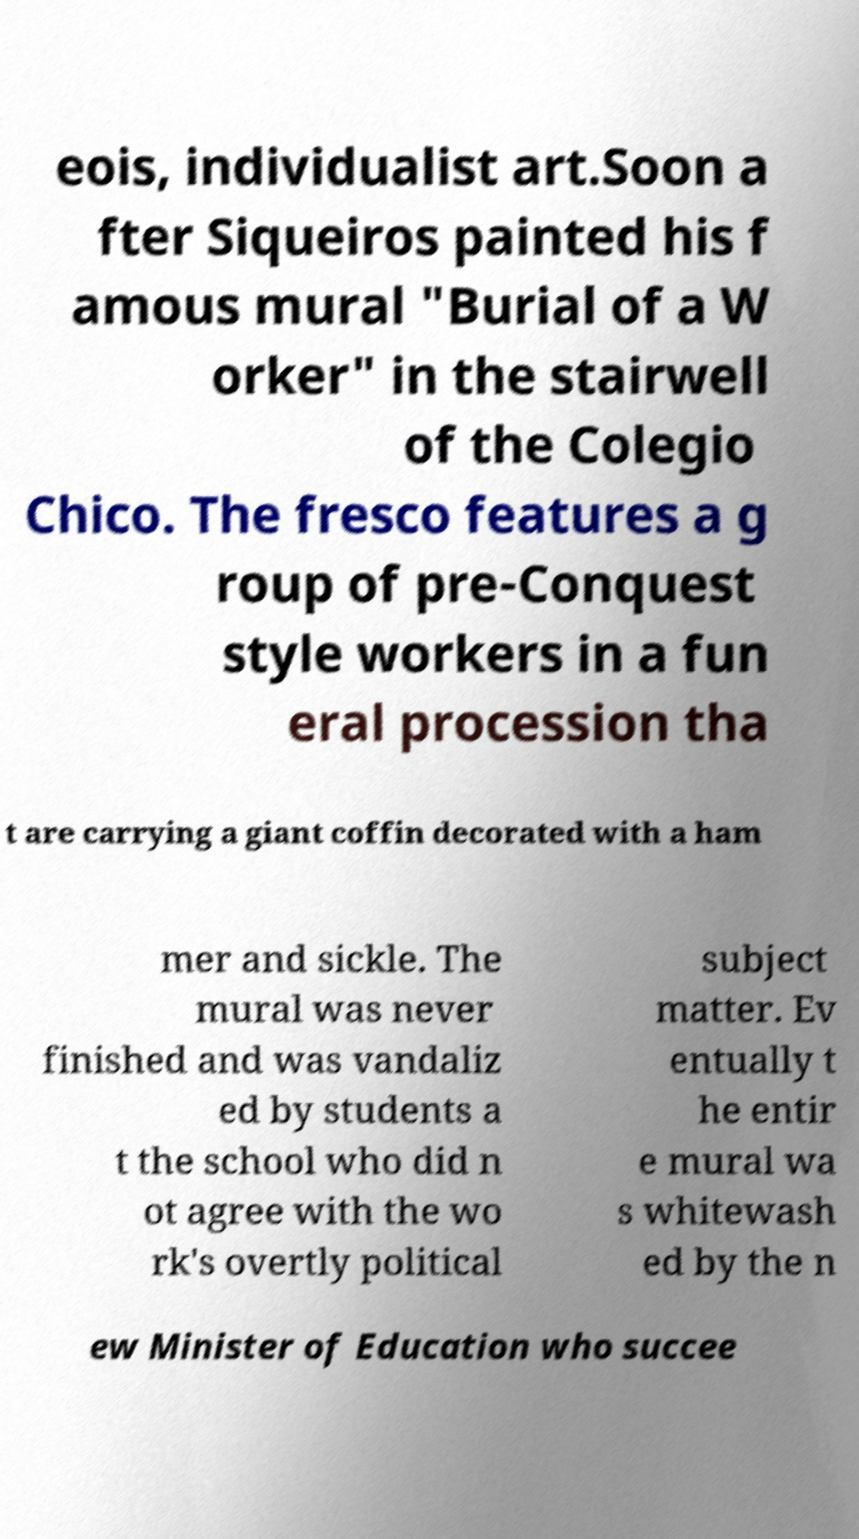Could you assist in decoding the text presented in this image and type it out clearly? eois, individualist art.Soon a fter Siqueiros painted his f amous mural "Burial of a W orker" in the stairwell of the Colegio Chico. The fresco features a g roup of pre-Conquest style workers in a fun eral procession tha t are carrying a giant coffin decorated with a ham mer and sickle. The mural was never finished and was vandaliz ed by students a t the school who did n ot agree with the wo rk's overtly political subject matter. Ev entually t he entir e mural wa s whitewash ed by the n ew Minister of Education who succee 